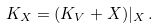<formula> <loc_0><loc_0><loc_500><loc_500>K _ { X } = ( K _ { V } + X ) | _ { X } \, .</formula> 